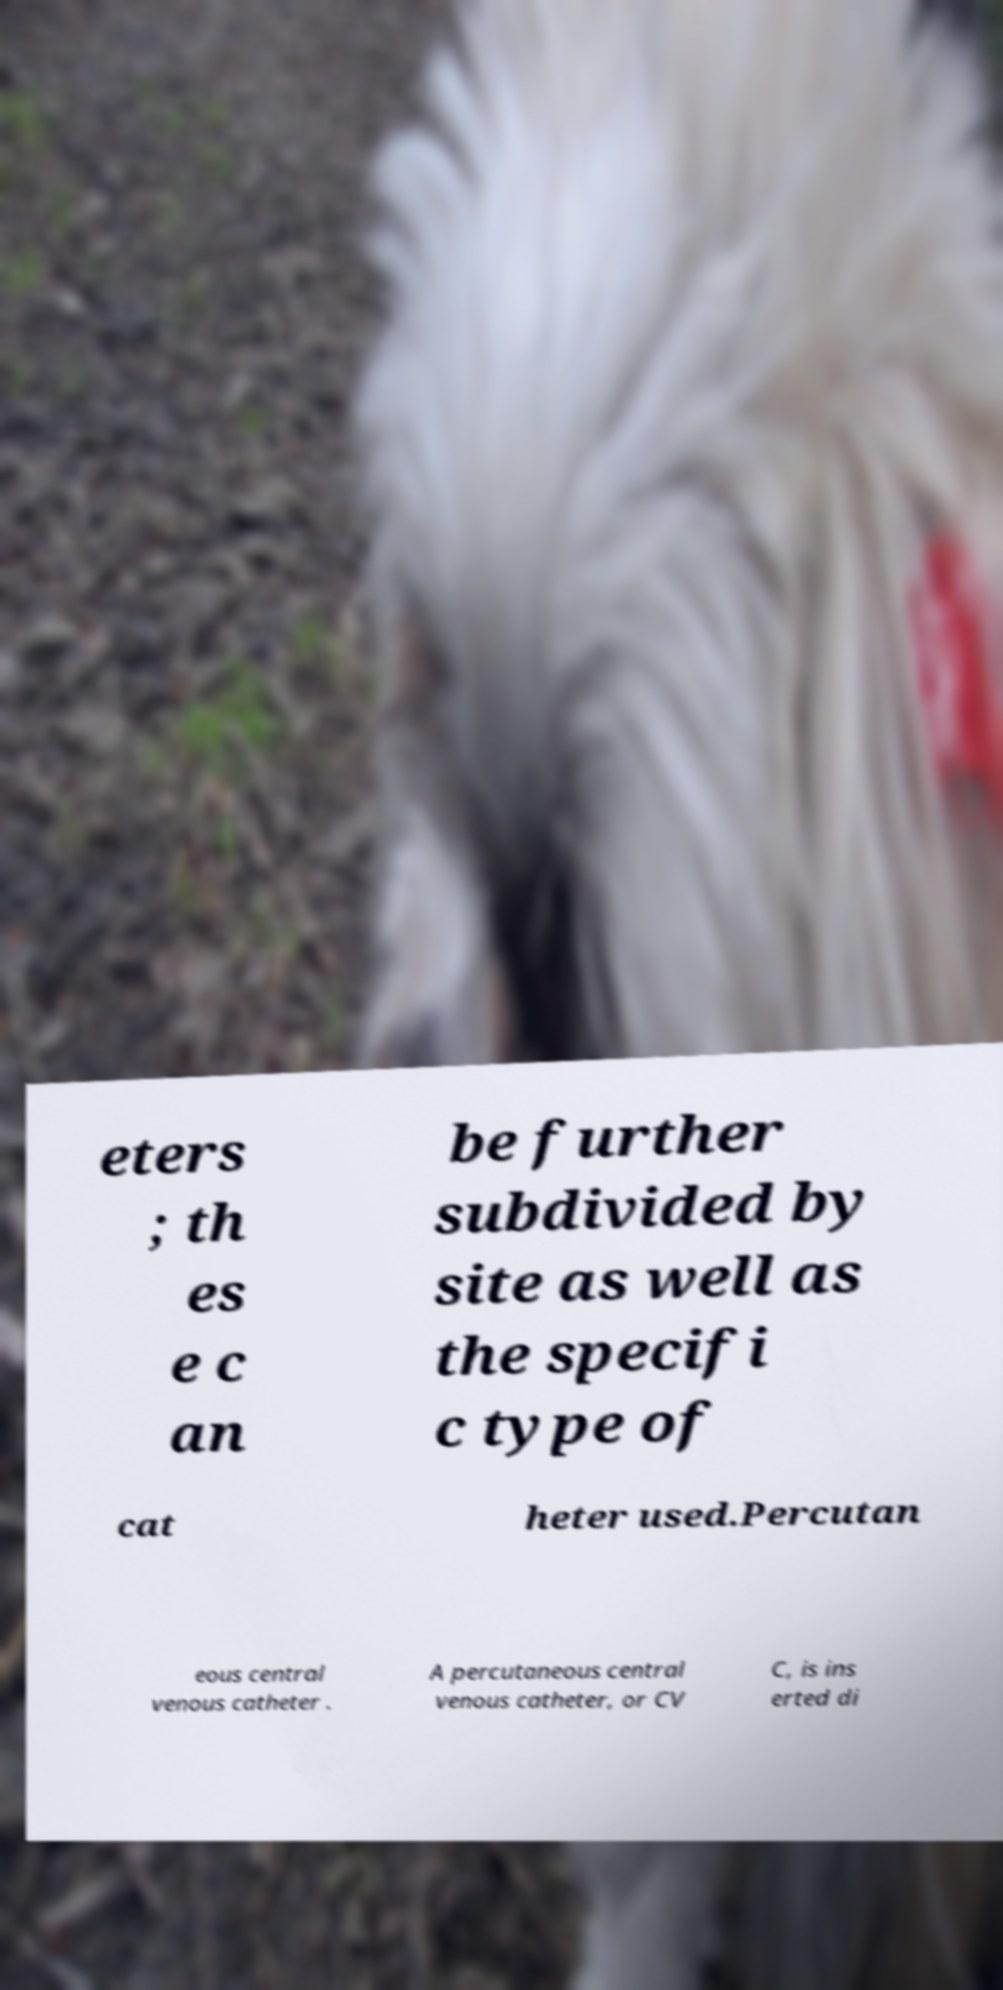Could you extract and type out the text from this image? eters ; th es e c an be further subdivided by site as well as the specifi c type of cat heter used.Percutan eous central venous catheter . A percutaneous central venous catheter, or CV C, is ins erted di 